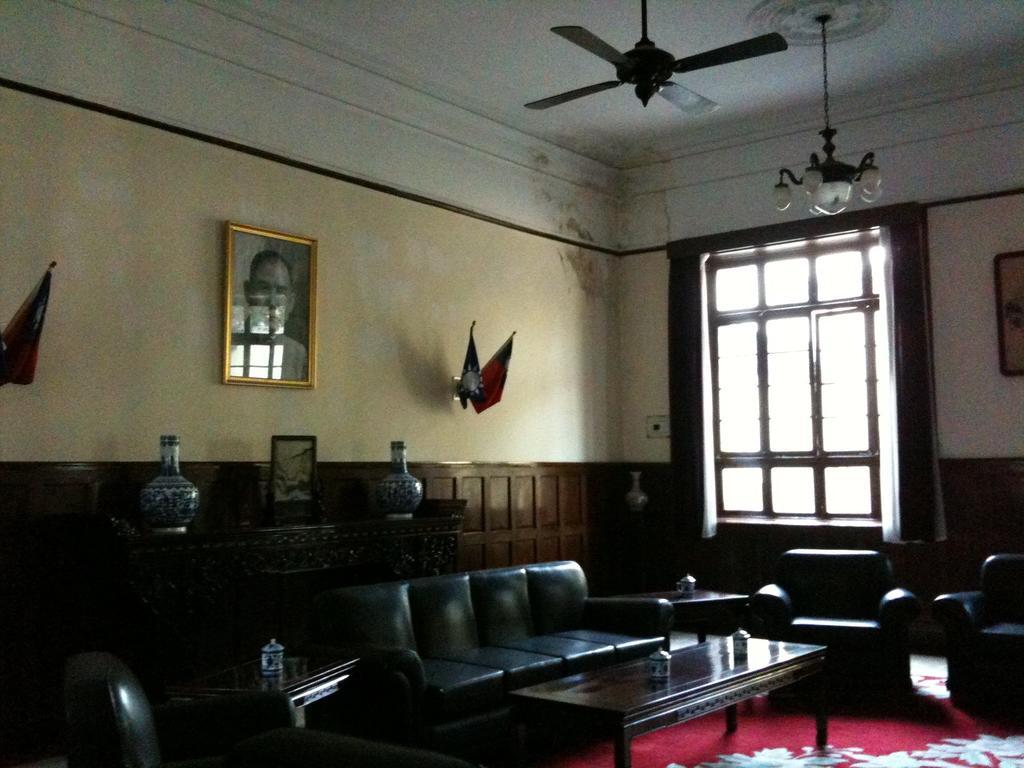In one or two sentences, can you explain what this image depicts? This picture is of inside the room. In the foreground we can see the sofas and the number of tables and a floor carpet. On the top there is a ceiling fan and a lamp. In the background we can see a wall, picture frame hanging on a wall and wall mounted flags. There is a table on the top of which two pots are placed. On the right we can see a door and a curtain. 